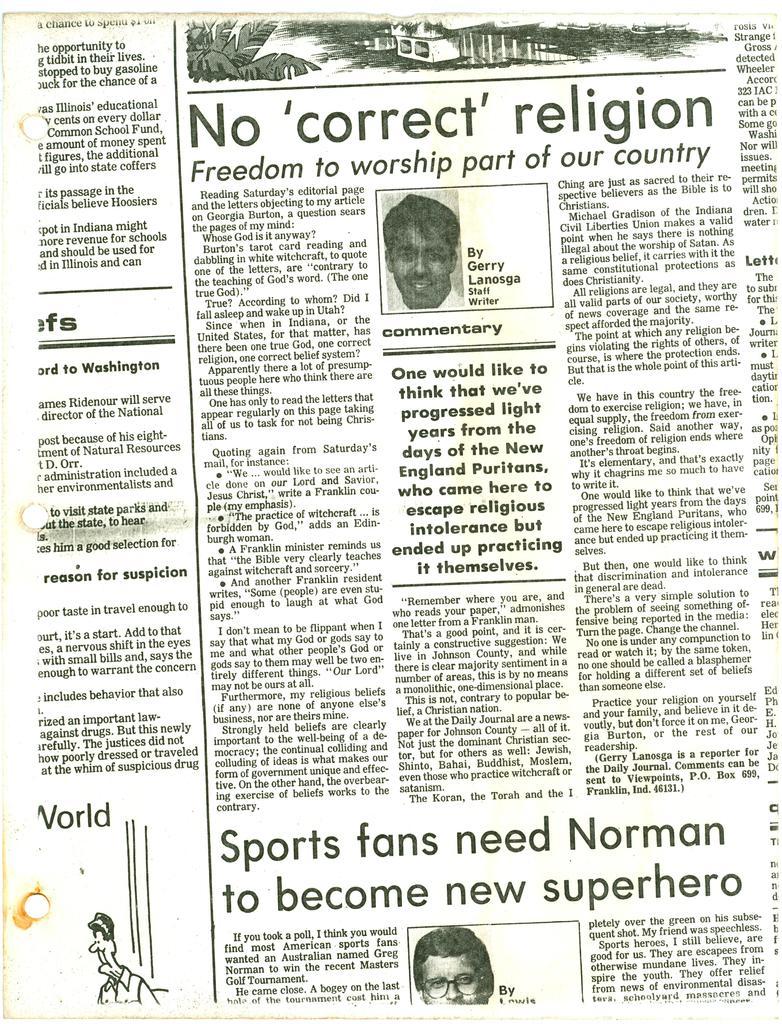Describe this image in one or two sentences. In this image I see the paper on which there are words written and I see a cartoon picture over here and I see 2 pictures of persons. 